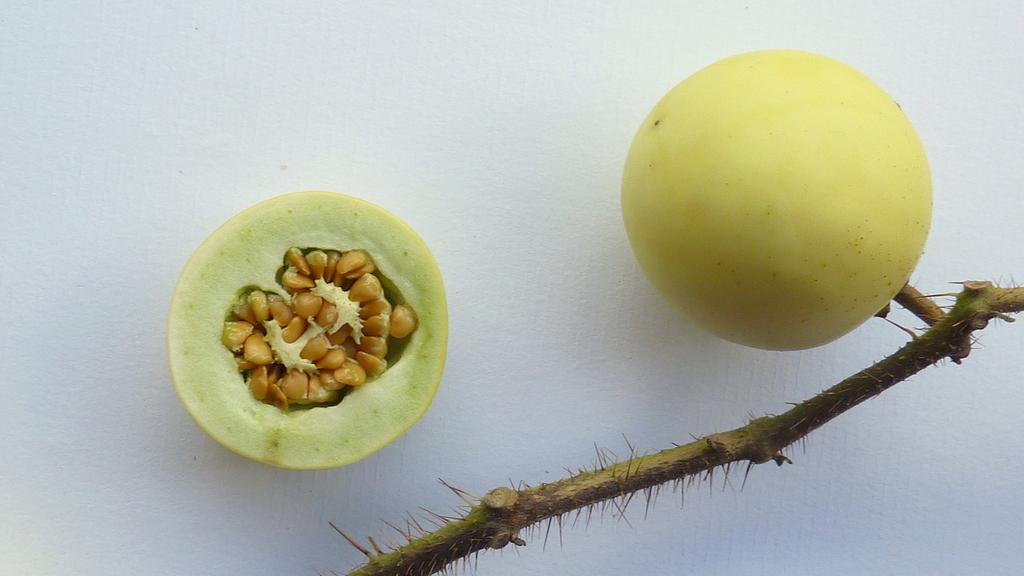What is the main subject in the center of the image? There is a fruit in the center of the image. Can you describe the fruit on the left side of the image? The fruit on the left side of the image is half sliced. What can be seen at the bottom of the image? There is a stem at the bottom of the image. What color is the background of the image? The background of the image is white. What type of skirt is the fruit wearing in the image? There are no skirts or clothing items present in the image, as the subjects are fruits. 